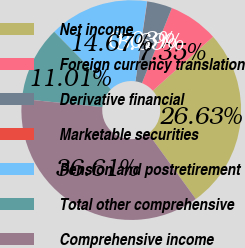<chart> <loc_0><loc_0><loc_500><loc_500><pie_chart><fcel>Net income<fcel>Foreign currency translation<fcel>Derivative financial<fcel>Marketable securities<fcel>Pension and postretirement<fcel>Total other comprehensive<fcel>Comprehensive income<nl><fcel>26.63%<fcel>7.35%<fcel>3.69%<fcel>0.03%<fcel>14.67%<fcel>11.01%<fcel>36.61%<nl></chart> 